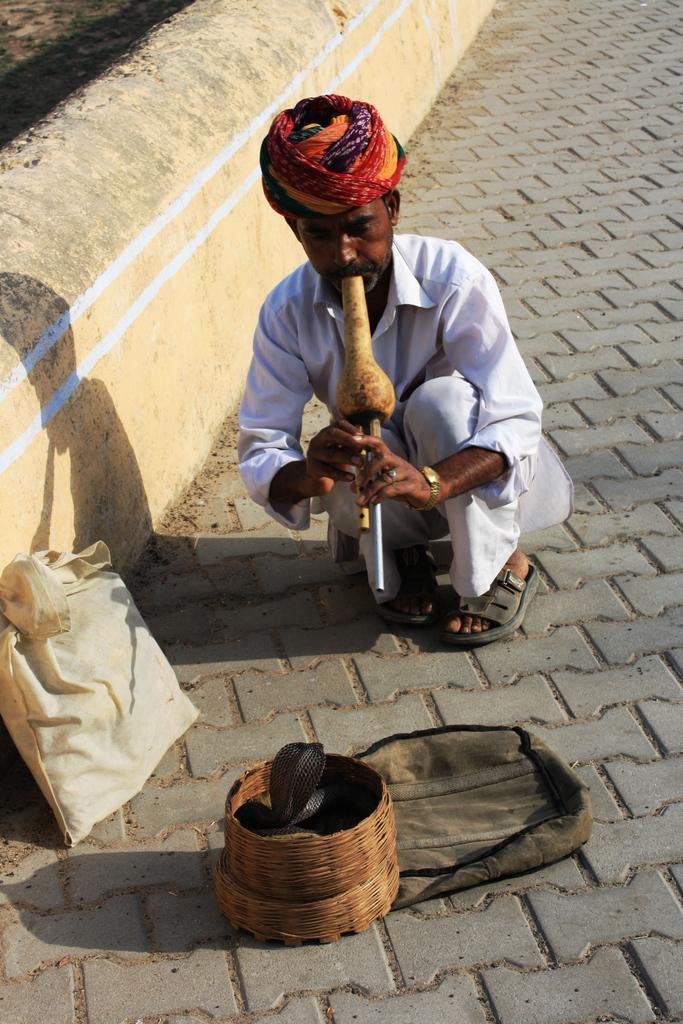How would you summarize this image in a sentence or two? In this image I can see a man is in a squat position and holding some object in hands. Here I can see a snake in a wooden basket, a bag and other objects. The man is wearing white color clothes. 